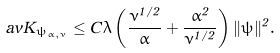<formula> <loc_0><loc_0><loc_500><loc_500>\ a v { K } _ { \psi _ { \alpha , \nu } } \leq C \lambda \left ( \frac { \nu ^ { 1 / 2 } } { \alpha } + \frac { \alpha ^ { 2 } } { \nu ^ { 1 / 2 } } \right ) \| \psi \| ^ { 2 } .</formula> 